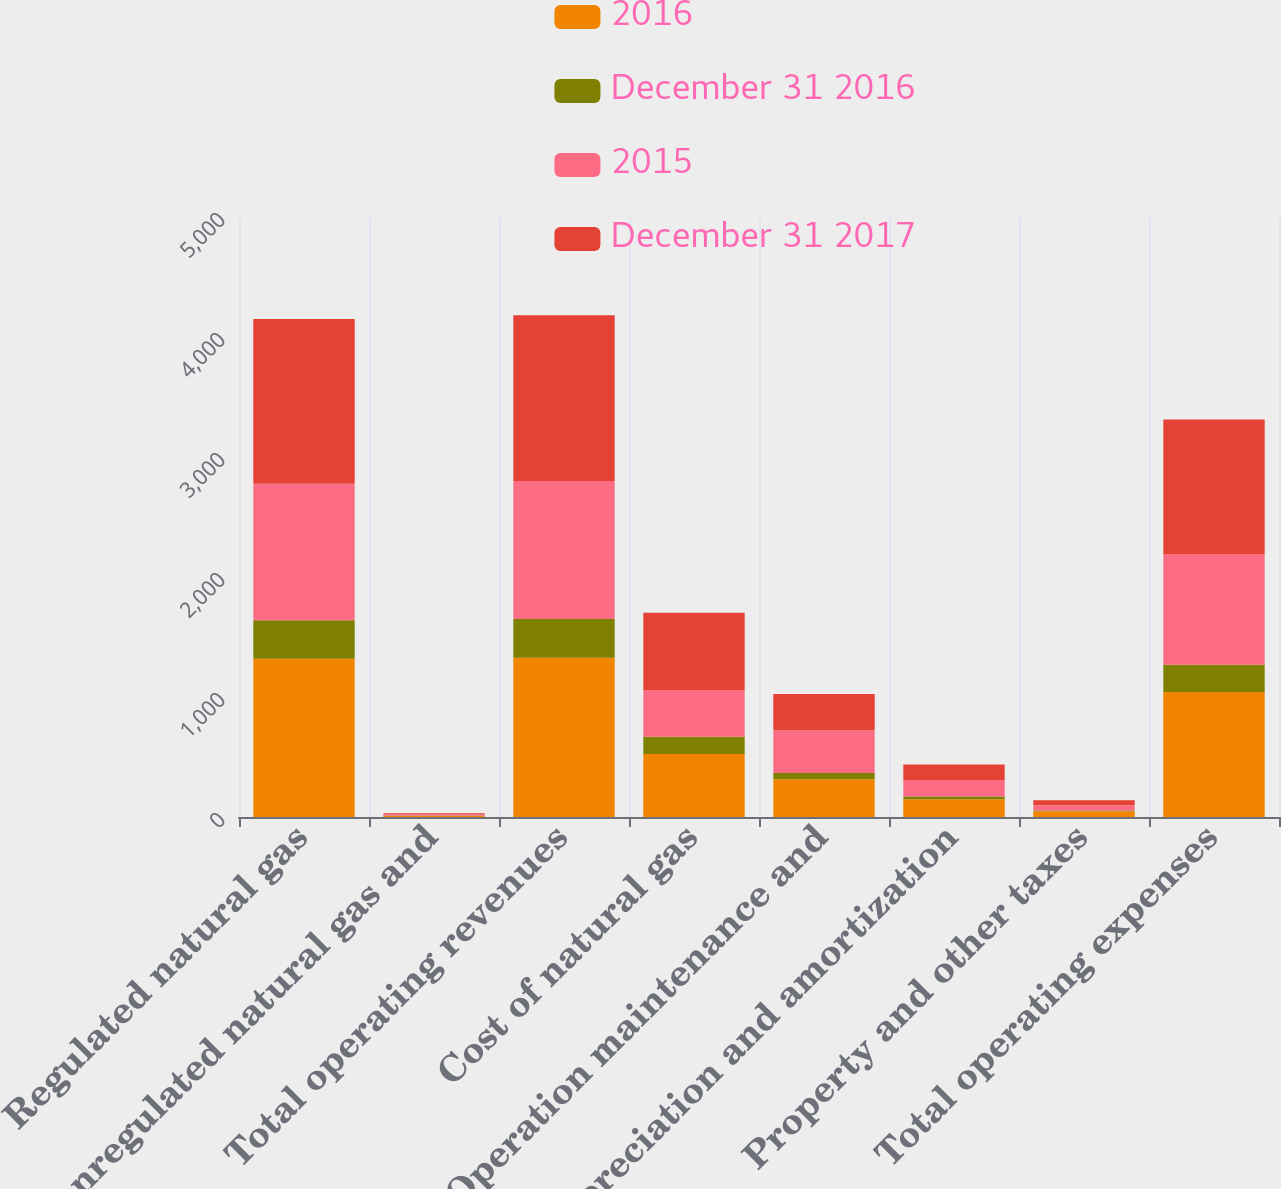Convert chart. <chart><loc_0><loc_0><loc_500><loc_500><stacked_bar_chart><ecel><fcel>Regulated natural gas<fcel>Nonregulated natural gas and<fcel>Total operating revenues<fcel>Cost of natural gas<fcel>Operation maintenance and<fcel>Depreciation and amortization<fcel>Property and other taxes<fcel>Total operating expenses<nl><fcel>2016<fcel>1319<fcel>9<fcel>1328<fcel>524<fcel>315<fcel>148<fcel>48<fcel>1042<nl><fcel>December 31 2016<fcel>320<fcel>2<fcel>322<fcel>144<fcel>52<fcel>23<fcel>7<fcel>226<nl><fcel>2015<fcel>1139<fcel>10<fcel>1149<fcel>391<fcel>353<fcel>137<fcel>43<fcel>924<nl><fcel>December 31 2017<fcel>1372<fcel>11<fcel>1383<fcel>644<fcel>305<fcel>129<fcel>42<fcel>1120<nl></chart> 